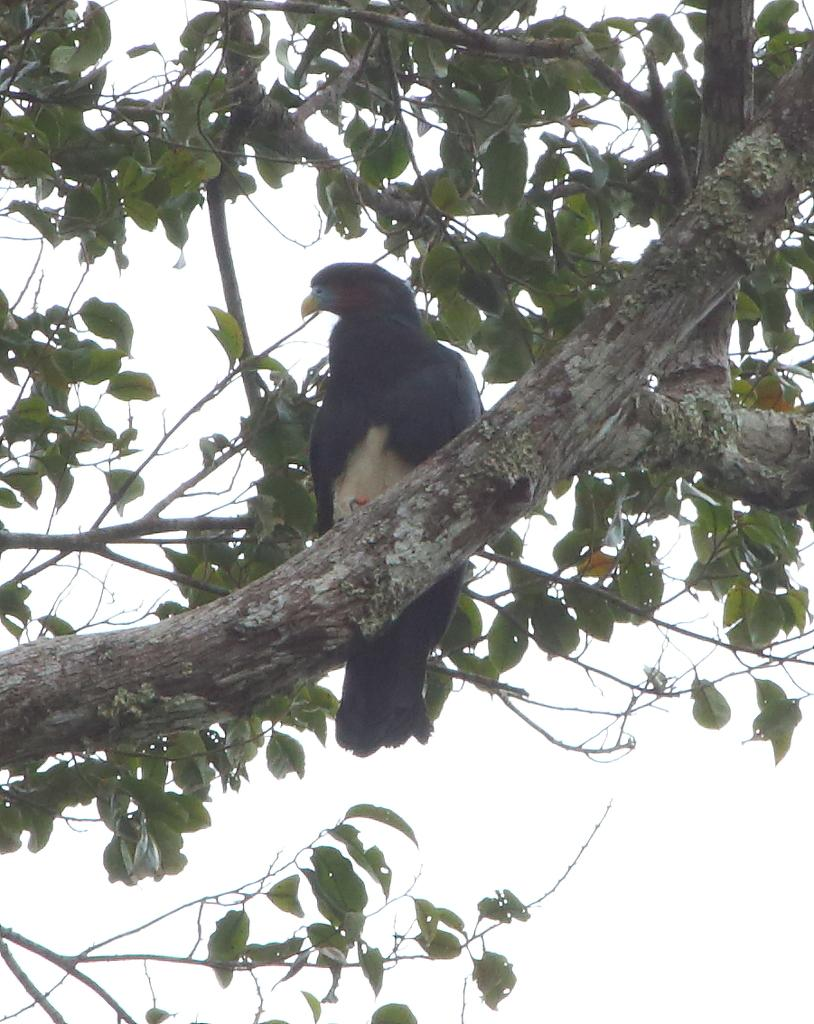What type of bird can be seen in the image? There is a black color bird in the image. Where is the bird located? The bird is on a tree. In which direction is the bird looking? The bird is looking towards the left side. What color are the leaves on the tree? There are green-colored leaves in the image. Can you tell me how many tickets the bird is holding in the image? There are no tickets present in the image; it features a bird on a tree. Is the bird sleeping in the image? The bird is not sleeping in the image; it is looking towards the left side. 